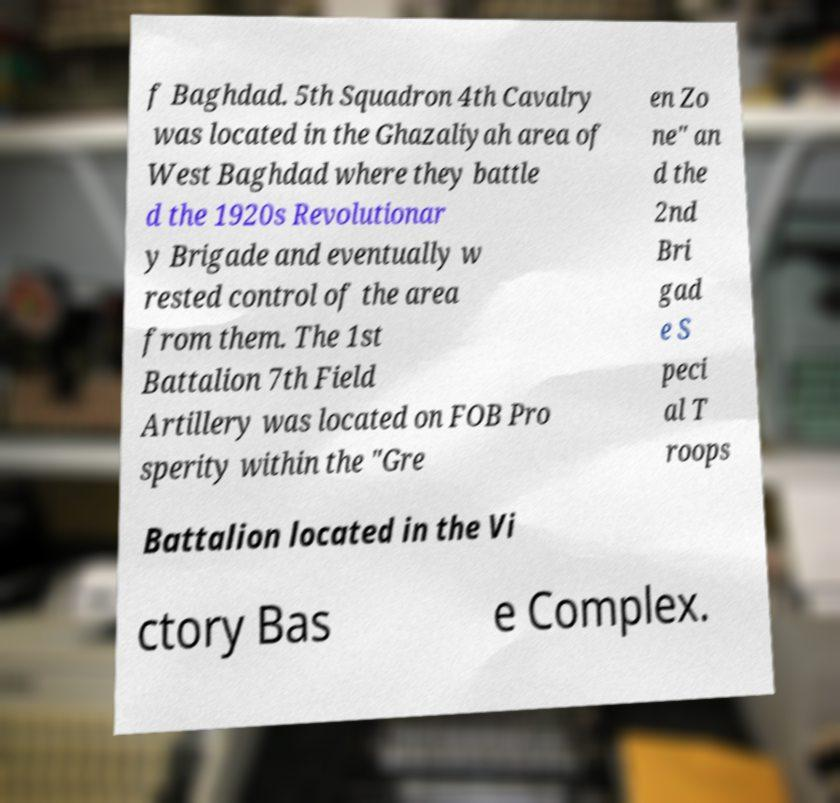I need the written content from this picture converted into text. Can you do that? f Baghdad. 5th Squadron 4th Cavalry was located in the Ghazaliyah area of West Baghdad where they battle d the 1920s Revolutionar y Brigade and eventually w rested control of the area from them. The 1st Battalion 7th Field Artillery was located on FOB Pro sperity within the "Gre en Zo ne" an d the 2nd Bri gad e S peci al T roops Battalion located in the Vi ctory Bas e Complex. 